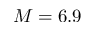<formula> <loc_0><loc_0><loc_500><loc_500>M = 6 . 9</formula> 